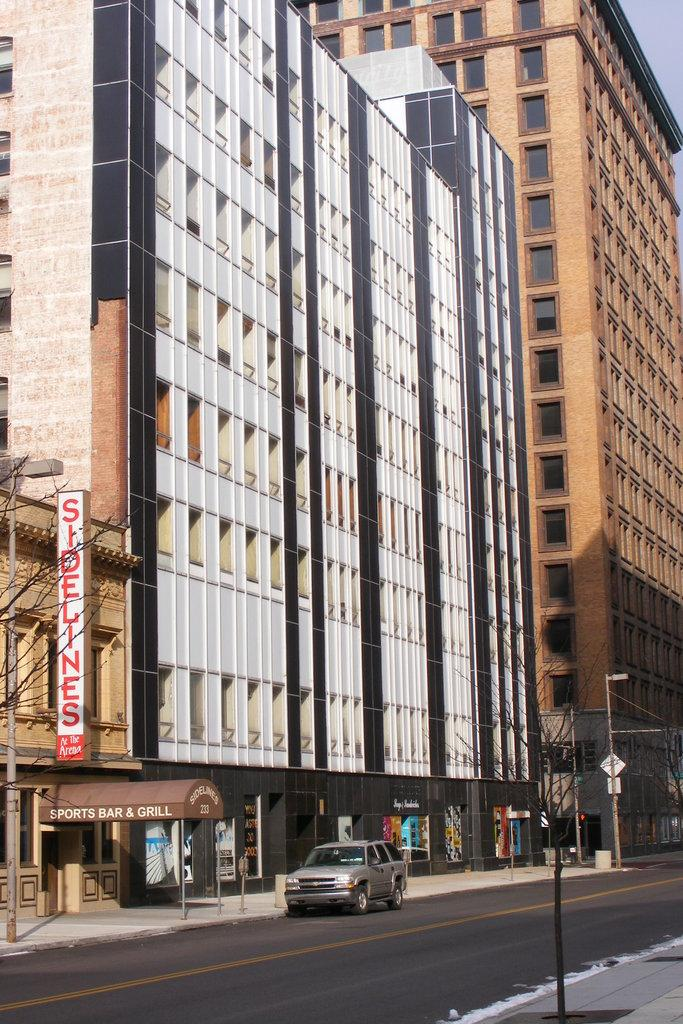Where was the picture taken? The picture was taken outside. What is the main subject in the center of the image? There is a car parked in the center of the image. How is the car positioned in the image? The car is parked on the ground. What can be seen in the distance behind the car? There are buildings and the sky visible in the background of the image. Are there any other objects or features visible in the background? Yes, there are other objects present in the background of the image. How does the car control the sneezing of the town in the image? There is no indication in the image that the car has any control over sneezing or that there is a town present. 